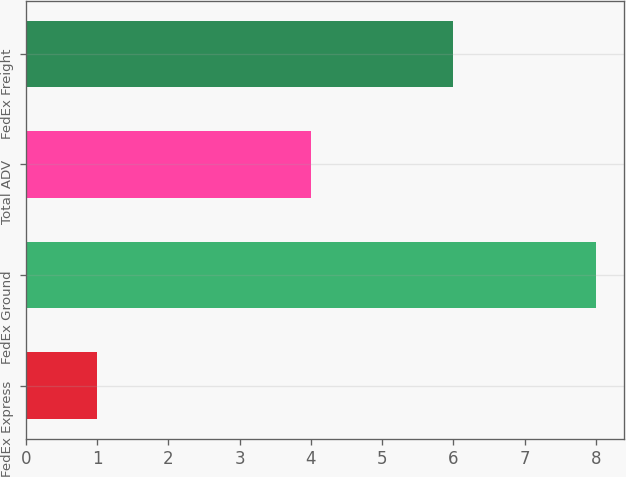<chart> <loc_0><loc_0><loc_500><loc_500><bar_chart><fcel>FedEx Express<fcel>FedEx Ground<fcel>Total ADV<fcel>FedEx Freight<nl><fcel>1<fcel>8<fcel>4<fcel>6<nl></chart> 